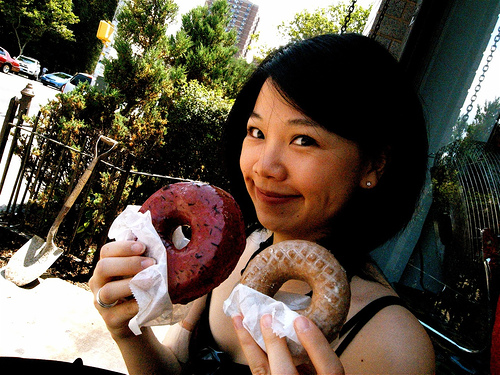How many fingernails are visible? 5 